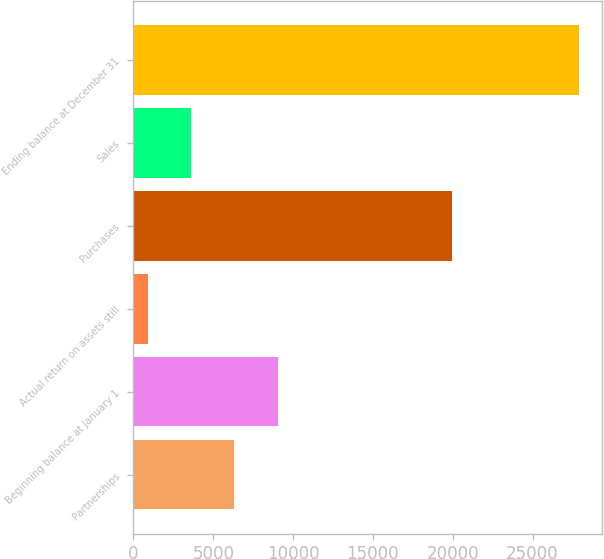<chart> <loc_0><loc_0><loc_500><loc_500><bar_chart><fcel>Partnerships<fcel>Beginning balance at January 1<fcel>Actual return on assets still<fcel>Purchases<fcel>Sales<fcel>Ending balance at December 31<nl><fcel>6327.4<fcel>9027.6<fcel>927<fcel>19984<fcel>3627.2<fcel>27929<nl></chart> 